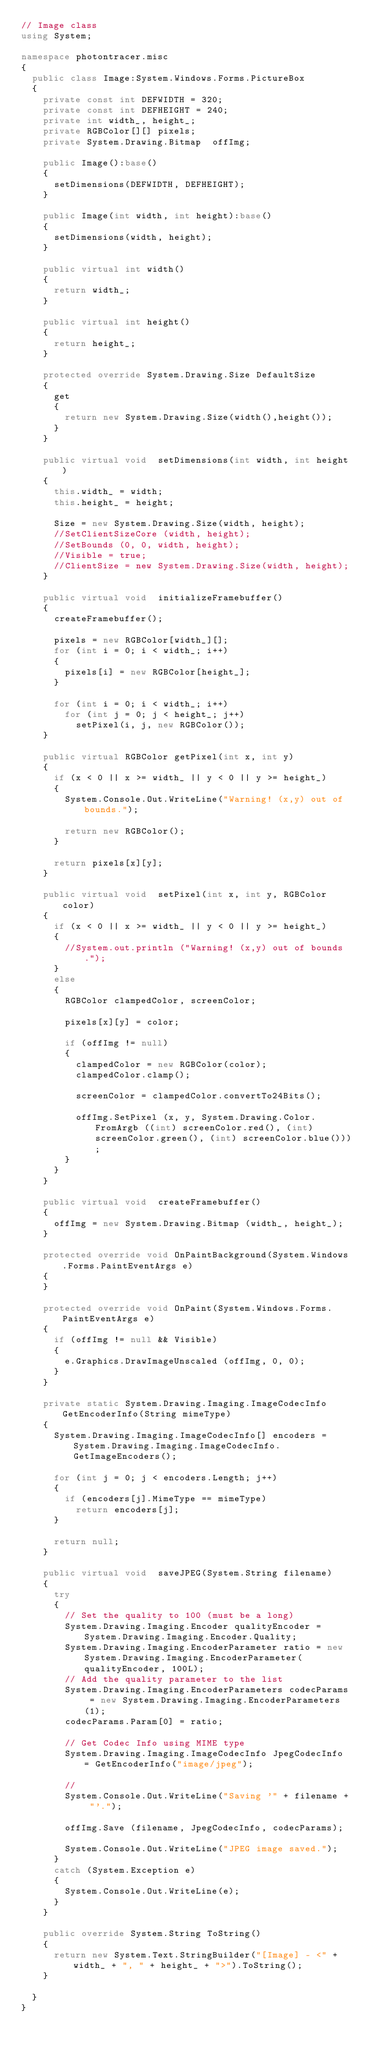Convert code to text. <code><loc_0><loc_0><loc_500><loc_500><_C#_>// Image class
using System;

namespace photontracer.misc
{	
	public class Image:System.Windows.Forms.PictureBox 
	{
		private const int DEFWIDTH = 320;
		private const int DEFHEIGHT = 240;
		private int width_, height_;
		private RGBColor[][] pixels;
		private System.Drawing.Bitmap  offImg;

		public Image():base()
		{
			setDimensions(DEFWIDTH, DEFHEIGHT);
		}
		
		public Image(int width, int height):base()
		{
			setDimensions(width, height);
		}

		public virtual int width()
		{
			return width_;
		}
		
		public virtual int height()
		{
			return height_;
		}
		
		protected override System.Drawing.Size DefaultSize
		{
			get
			{
				return new System.Drawing.Size(width(),height());
			}
		}

		public virtual void  setDimensions(int width, int height)
		{
			this.width_ = width;
			this.height_ = height;
			
			Size = new System.Drawing.Size(width, height);
			//SetClientSizeCore (width, height);
			//SetBounds (0, 0, width, height);
			//Visible = true;
			//ClientSize = new System.Drawing.Size(width, height);
		}
		
		public virtual void  initializeFramebuffer()
		{
			createFramebuffer();
			
			pixels = new RGBColor[width_][];
			for (int i = 0; i < width_; i++)
			{
				pixels[i] = new RGBColor[height_];
			}
			
			for (int i = 0; i < width_; i++)
				for (int j = 0; j < height_; j++)
					setPixel(i, j, new RGBColor());
		}
		
		public virtual RGBColor getPixel(int x, int y)
		{
			if (x < 0 || x >= width_ || y < 0 || y >= height_)
			{
				System.Console.Out.WriteLine("Warning! (x,y) out of bounds.");
				
				return new RGBColor();
			}
			
			return pixels[x][y];
		}
		
		public virtual void  setPixel(int x, int y, RGBColor color)
		{
			if (x < 0 || x >= width_ || y < 0 || y >= height_)
			{
				//System.out.println ("Warning! (x,y) out of bounds.");
			}
			else
			{
				RGBColor clampedColor, screenColor;
				
				pixels[x][y] = color;
				
				if (offImg != null)
				{
					clampedColor = new RGBColor(color);
					clampedColor.clamp();
					
					screenColor = clampedColor.convertTo24Bits();
					
					offImg.SetPixel (x, y, System.Drawing.Color.FromArgb ((int) screenColor.red(), (int) screenColor.green(), (int) screenColor.blue()));
				}
			}
		}
		
		public virtual void  createFramebuffer()
		{
			offImg = new System.Drawing.Bitmap (width_, height_);
		}

		protected override void OnPaintBackground(System.Windows.Forms.PaintEventArgs e) 
		{
		}
			
		protected override void OnPaint(System.Windows.Forms.PaintEventArgs e) 
		{
			if (offImg != null && Visible)
			{
				e.Graphics.DrawImageUnscaled (offImg, 0, 0);
			}
		}

		private static System.Drawing.Imaging.ImageCodecInfo GetEncoderInfo(String mimeType)
		{
			System.Drawing.Imaging.ImageCodecInfo[] encoders = System.Drawing.Imaging.ImageCodecInfo.GetImageEncoders();

			for (int j = 0; j < encoders.Length; j++)
			{
				if (encoders[j].MimeType == mimeType)
					return encoders[j];
			} 
			
			return null;
		}

		public virtual void  saveJPEG(System.String filename)
		{
			try
			{
				// Set the quality to 100 (must be a long)
				System.Drawing.Imaging.Encoder qualityEncoder = System.Drawing.Imaging.Encoder.Quality;
				System.Drawing.Imaging.EncoderParameter ratio = new System.Drawing.Imaging.EncoderParameter(qualityEncoder, 100L);
				// Add the quality parameter to the list
				System.Drawing.Imaging.EncoderParameters codecParams = new System.Drawing.Imaging.EncoderParameters(1);
				codecParams.Param[0] = ratio;

				// Get Codec Info using MIME type
				System.Drawing.Imaging.ImageCodecInfo JpegCodecInfo = GetEncoderInfo("image/jpeg");

				//
				System.Console.Out.WriteLine("Saving '" + filename + "'.");
				
				offImg.Save (filename, JpegCodecInfo, codecParams);
				
				System.Console.Out.WriteLine("JPEG image saved.");
			}
			catch (System.Exception e)
			{
				System.Console.Out.WriteLine(e);
			}
		}
	
		public override System.String ToString()
		{
			return new System.Text.StringBuilder("[Image] - <" + width_ + ", " + height_ + ">").ToString();
		}

	}
}</code> 